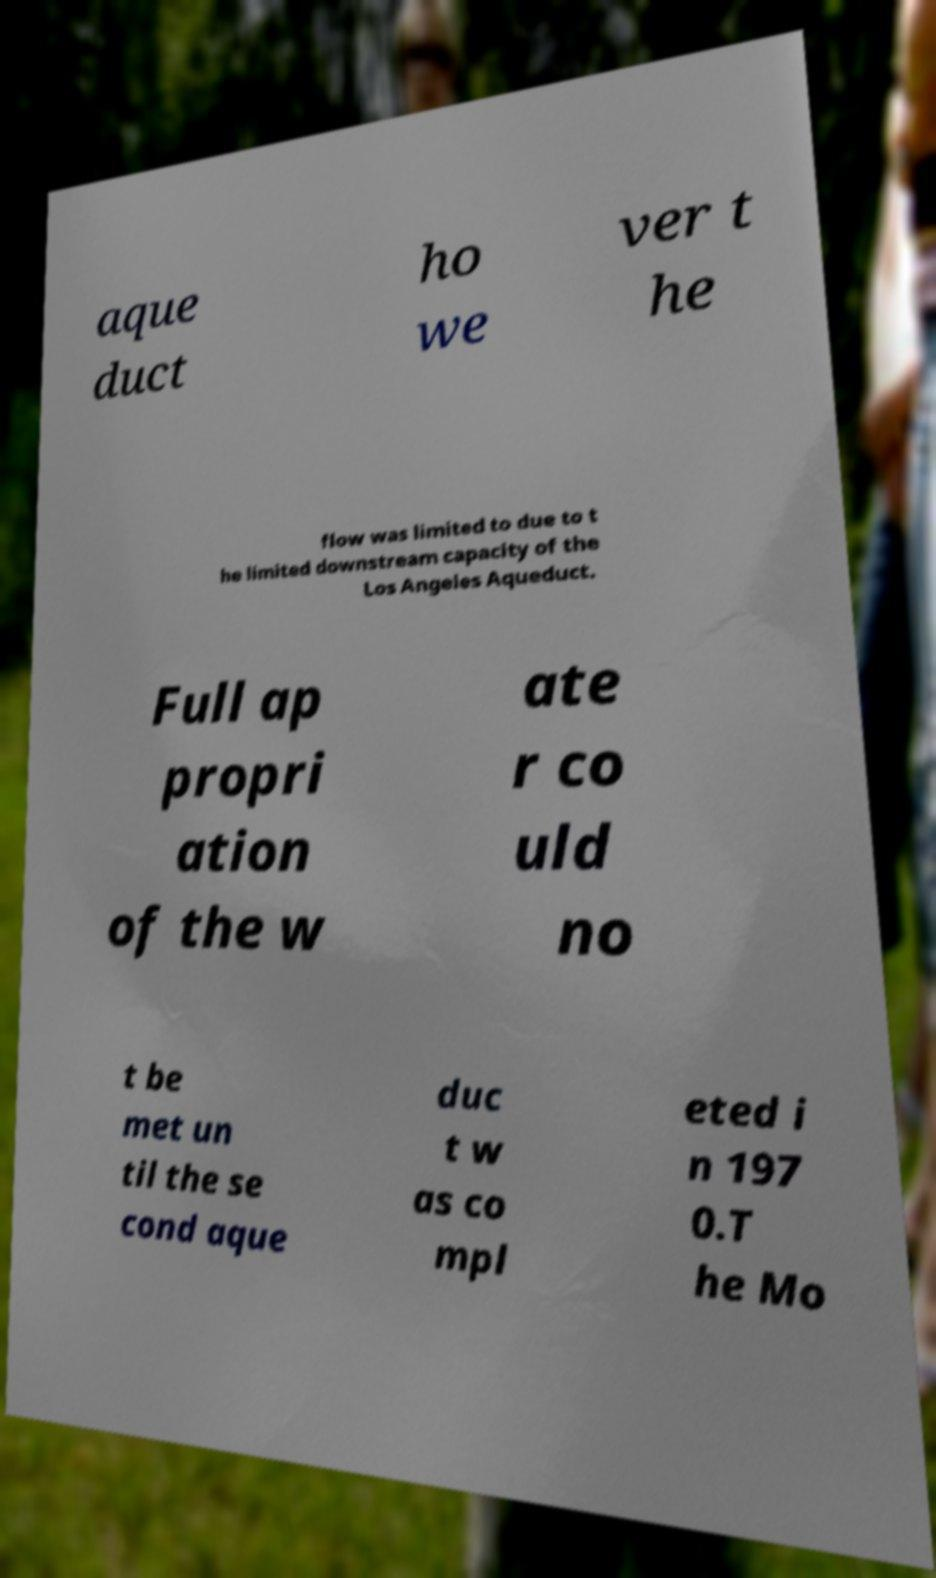Could you extract and type out the text from this image? aque duct ho we ver t he flow was limited to due to t he limited downstream capacity of the Los Angeles Aqueduct. Full ap propri ation of the w ate r co uld no t be met un til the se cond aque duc t w as co mpl eted i n 197 0.T he Mo 